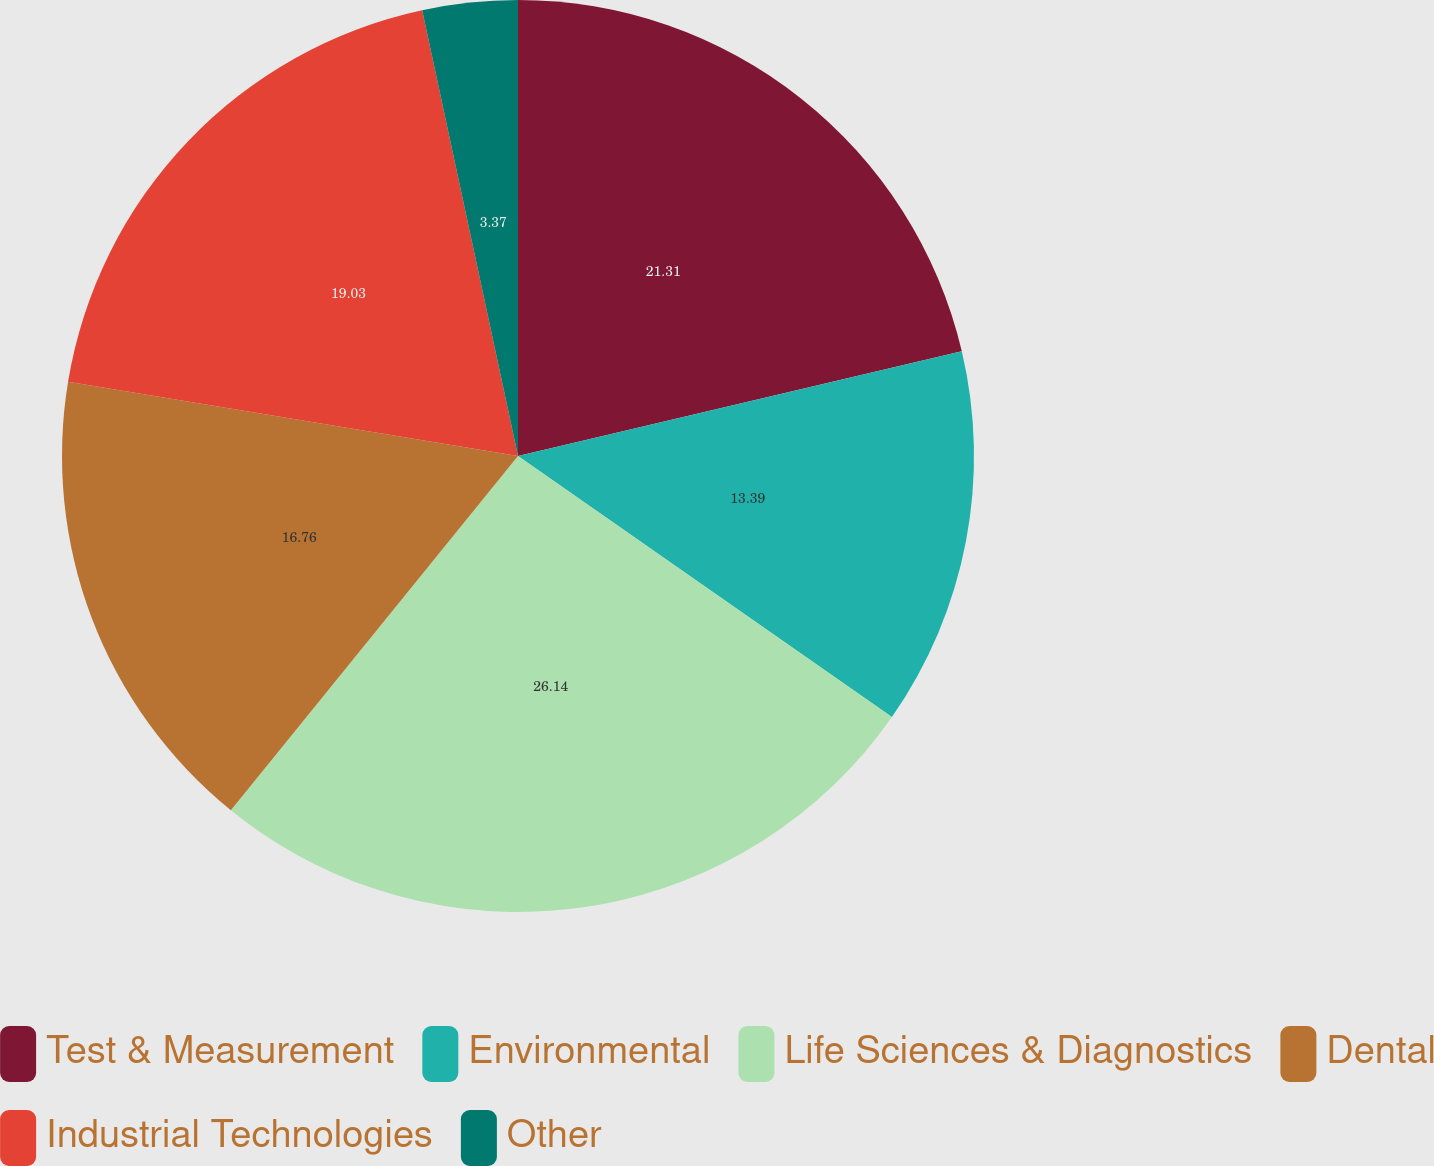<chart> <loc_0><loc_0><loc_500><loc_500><pie_chart><fcel>Test & Measurement<fcel>Environmental<fcel>Life Sciences & Diagnostics<fcel>Dental<fcel>Industrial Technologies<fcel>Other<nl><fcel>21.31%<fcel>13.39%<fcel>26.14%<fcel>16.76%<fcel>19.03%<fcel>3.37%<nl></chart> 